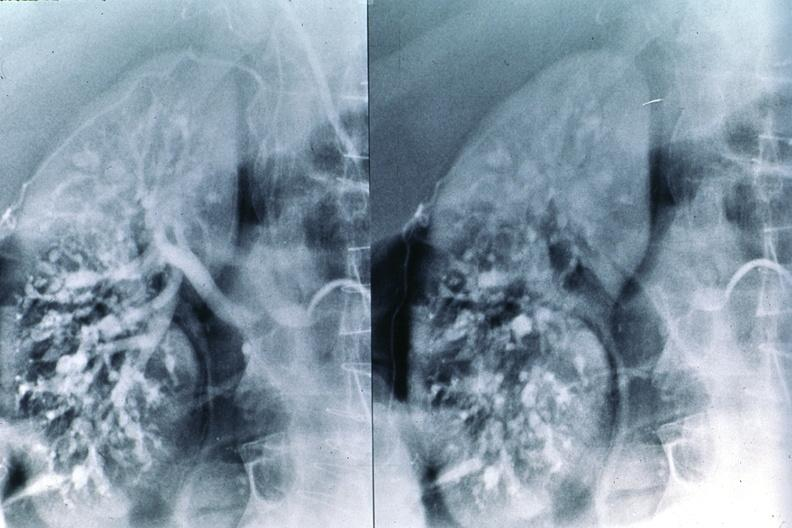where is this?
Answer the question using a single word or phrase. Urinary 